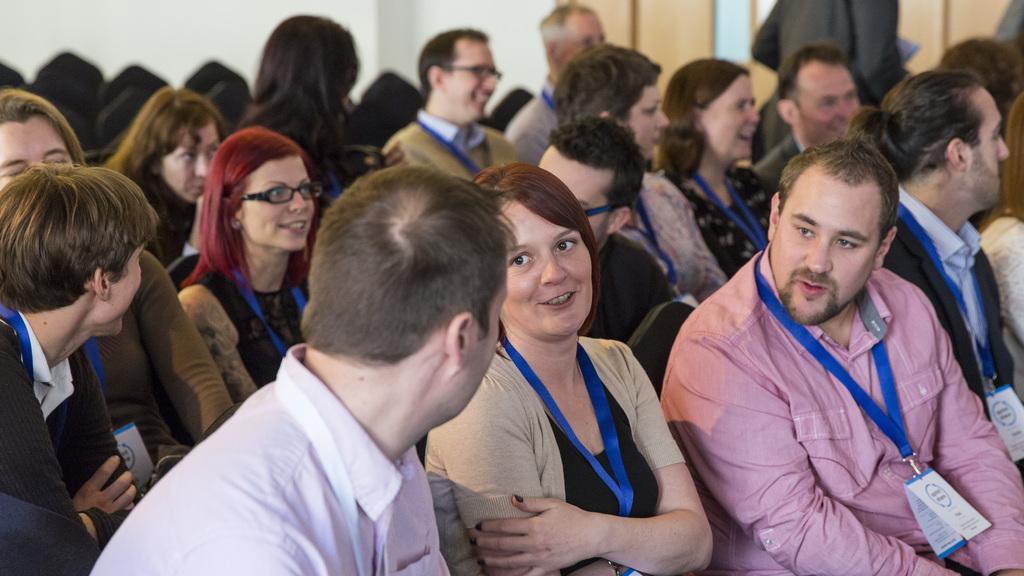Describe this image in one or two sentences. In this image there are people sitting on chairs, in the background it is blurred. 